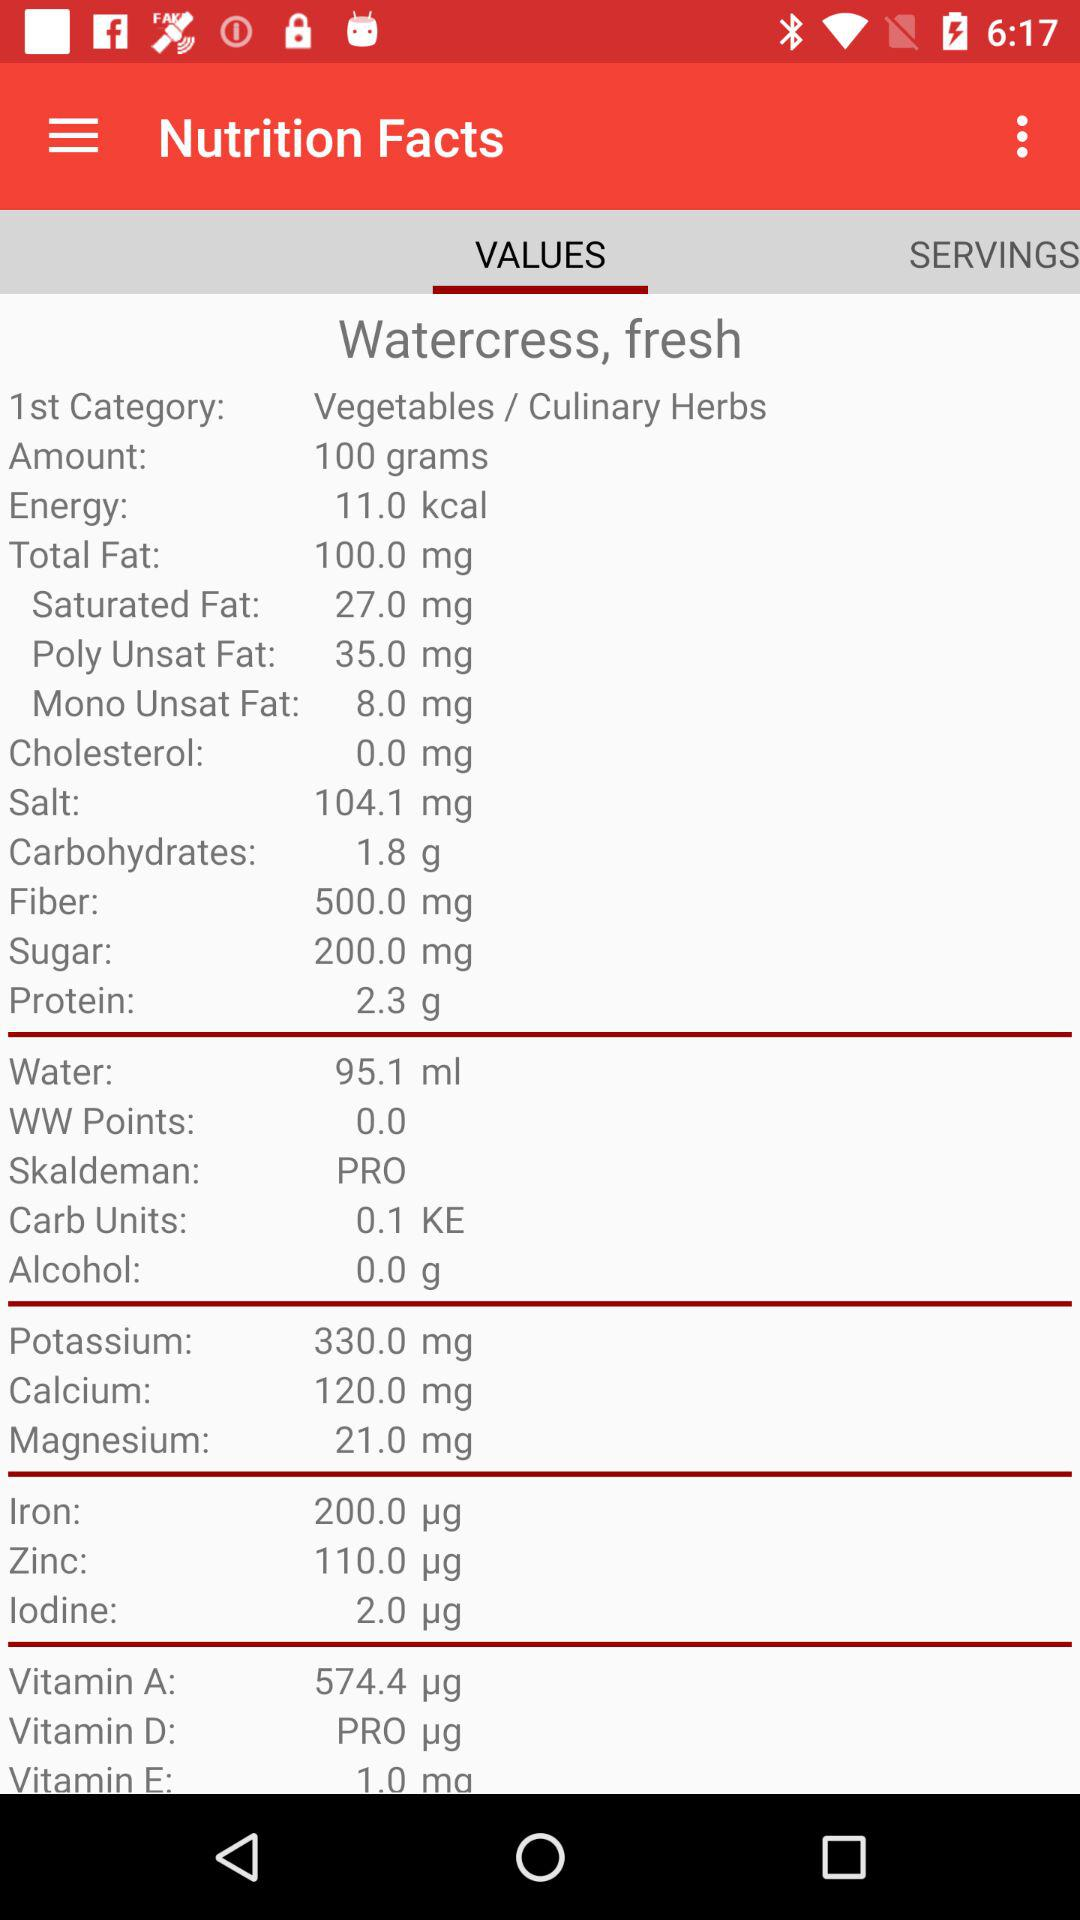What is the serving size of watercress?
Answer the question using a single word or phrase. 100 grams 